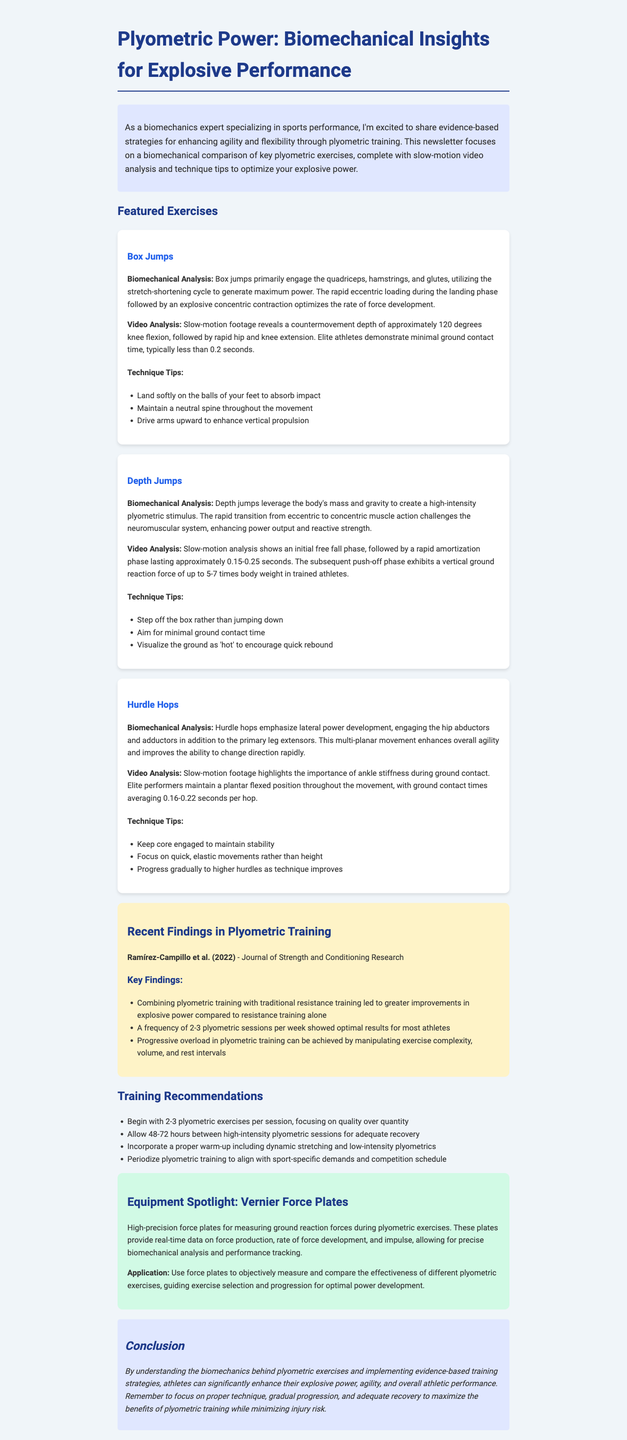What is the title of the newsletter? The title is prominently stated at the beginning of the document.
Answer: Plyometric Power: Biomechanical Insights for Explosive Performance Who are the authors of the featured study in the research spotlight? The authors' names are mentioned in the research spotlight section.
Answer: Ramírez-Campillo et al What year was the research study published? The publication year is listed alongside the authors in the document.
Answer: 2022 What is the recommended frequency of plyometric sessions per week for optimal results? The document specifies an optimal training frequency for athletes.
Answer: 2-3 How long is the amortization phase in depth jumps? The amortization phase timing is outlined in the biomechanical analysis of depth jumps.
Answer: Approximately 0.15-0.25 seconds Which exercise emphasizes lateral power development? This detail is mentioned in the biomechanical analysis section for one of the featured exercises.
Answer: Hurdle Hops What should athletes visualize to encourage a quick rebound in depth jumps? This information is provided in the technique tips for depth jumps.
Answer: Visualize the ground as 'hot' What is the application of Vernier Force Plates? This application is described in the equipment spotlight section of the newsletter.
Answer: Measure ground reaction forces during plyometric exercises How many plyometric exercises should one begin with per session? This recommendation is made in the training recommendations section.
Answer: 2-3 